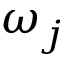<formula> <loc_0><loc_0><loc_500><loc_500>\omega _ { j }</formula> 